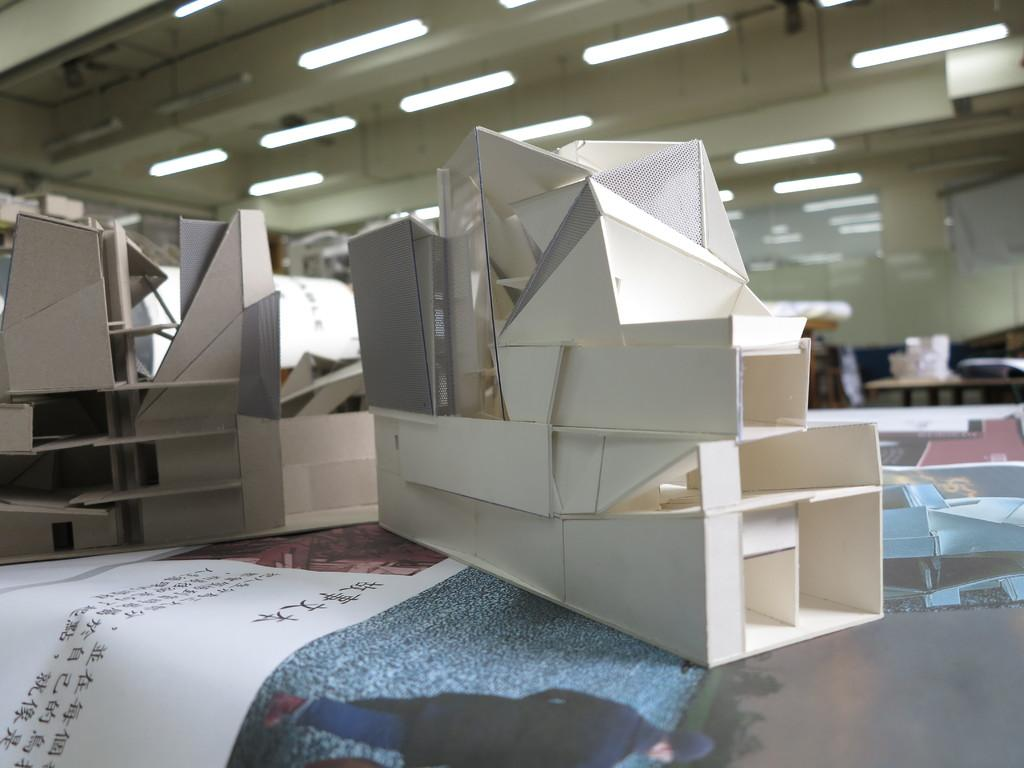What type of objects can be seen in the image? There are building models in the image. What can be seen hanging from the ceiling in the image? Lights are hanging from the ceiling in the image. Where is a specific paper located in the image? There is a paper in the bottom left of the image. What holiday song is being played in the background of the image? There is no indication of any music or holiday in the image, so it cannot be determined what song might be playing. 